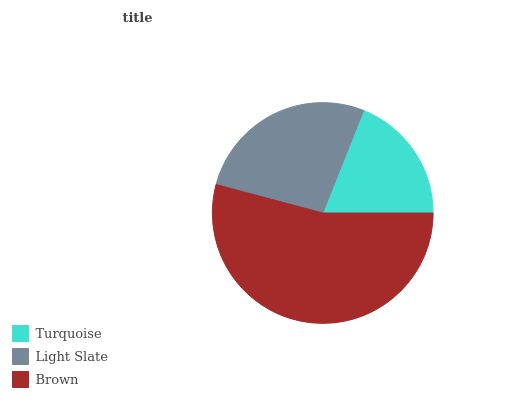Is Turquoise the minimum?
Answer yes or no. Yes. Is Brown the maximum?
Answer yes or no. Yes. Is Light Slate the minimum?
Answer yes or no. No. Is Light Slate the maximum?
Answer yes or no. No. Is Light Slate greater than Turquoise?
Answer yes or no. Yes. Is Turquoise less than Light Slate?
Answer yes or no. Yes. Is Turquoise greater than Light Slate?
Answer yes or no. No. Is Light Slate less than Turquoise?
Answer yes or no. No. Is Light Slate the high median?
Answer yes or no. Yes. Is Light Slate the low median?
Answer yes or no. Yes. Is Brown the high median?
Answer yes or no. No. Is Brown the low median?
Answer yes or no. No. 